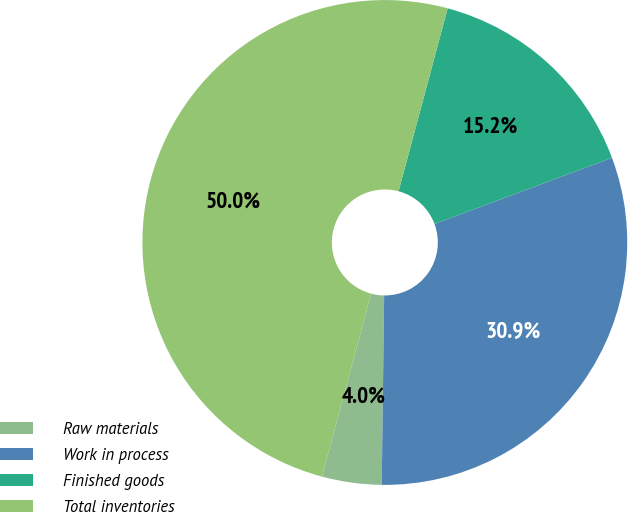Convert chart. <chart><loc_0><loc_0><loc_500><loc_500><pie_chart><fcel>Raw materials<fcel>Work in process<fcel>Finished goods<fcel>Total inventories<nl><fcel>3.97%<fcel>30.88%<fcel>15.15%<fcel>50.0%<nl></chart> 